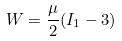Convert formula to latex. <formula><loc_0><loc_0><loc_500><loc_500>W = \frac { \mu } { 2 } ( I _ { 1 } - 3 )</formula> 